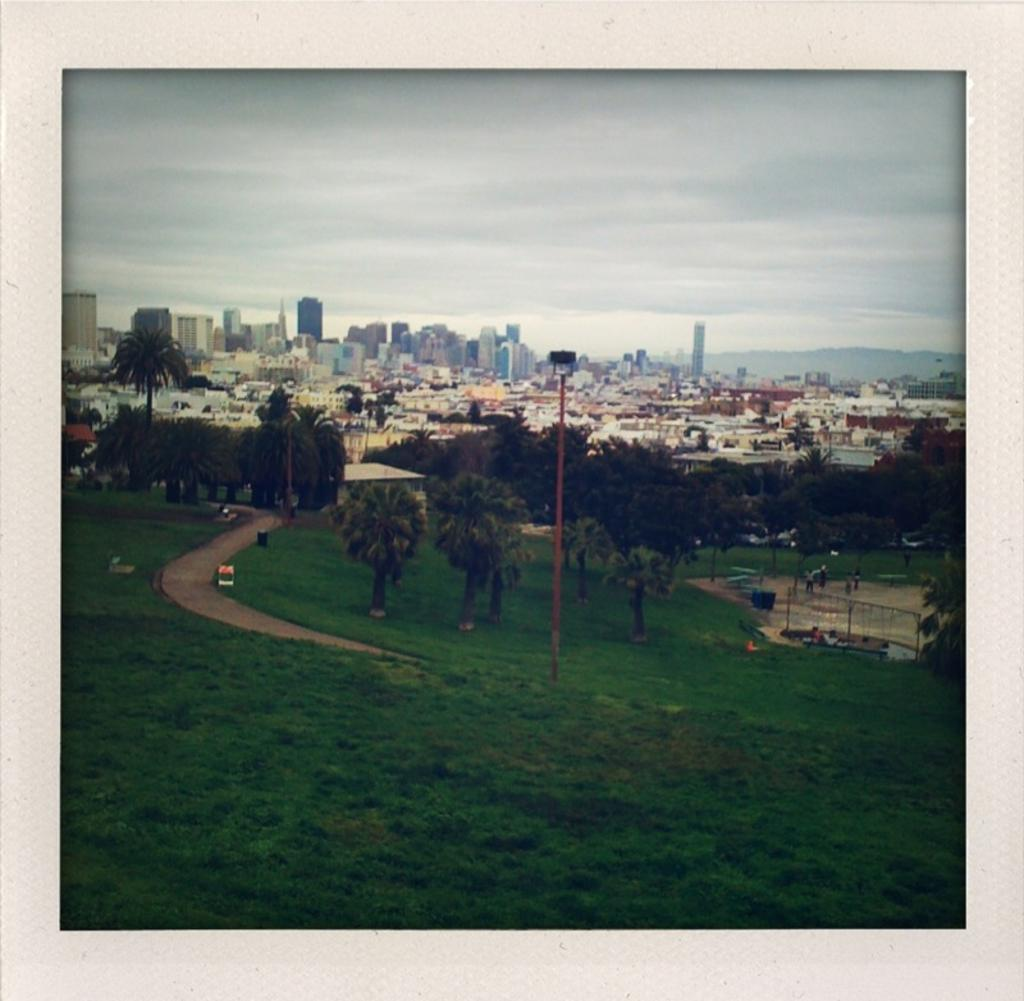What type of vegetation can be seen in the front of the image? There is a lot of greenery in the front of the image. Can you describe the vegetation in more detail? There are trees in the image. What type of urban environment is depicted in the image? The image contains a city with many buildings and houses. What natural feature can be seen in the background of the image? There is a mountain visible in the background of the image. What type of chain can be seen hanging from the trees in the image? There is no chain present in the image; it features greenery, trees, a city, and a mountain. Is there a coat draped over the mountain in the image? There is no coat present in the image; it only features a mountain in the background. 